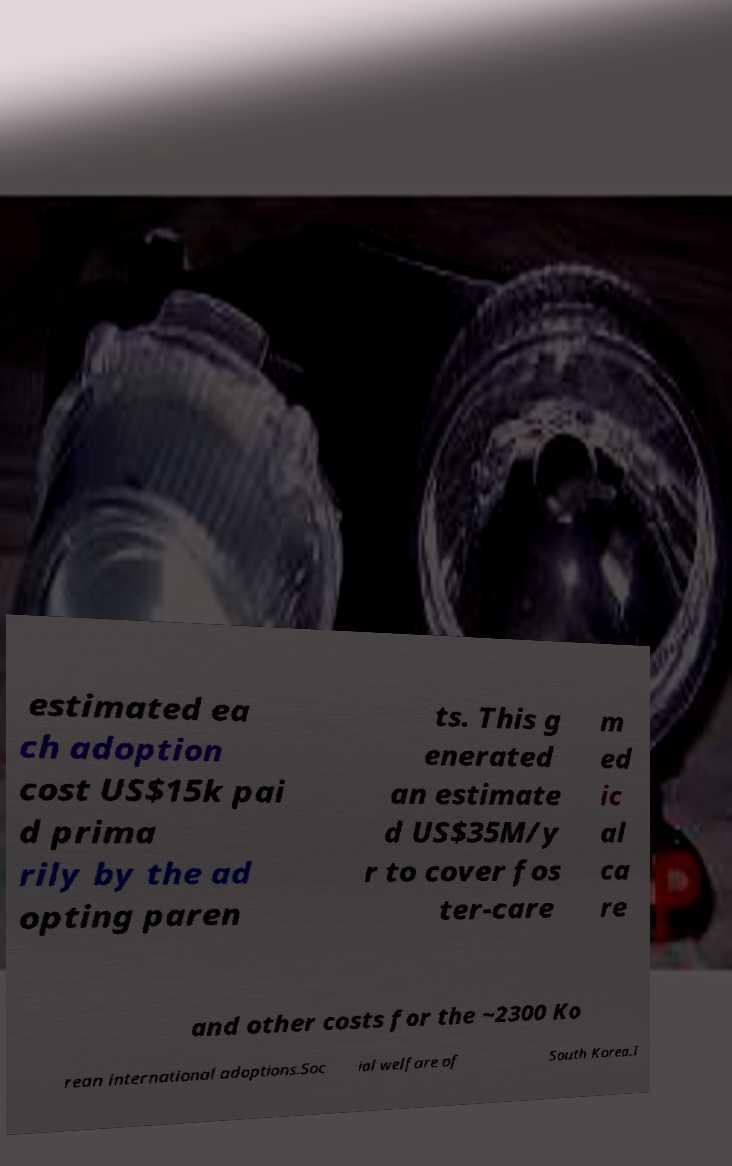There's text embedded in this image that I need extracted. Can you transcribe it verbatim? estimated ea ch adoption cost US$15k pai d prima rily by the ad opting paren ts. This g enerated an estimate d US$35M/y r to cover fos ter-care m ed ic al ca re and other costs for the ~2300 Ko rean international adoptions.Soc ial welfare of South Korea.I 